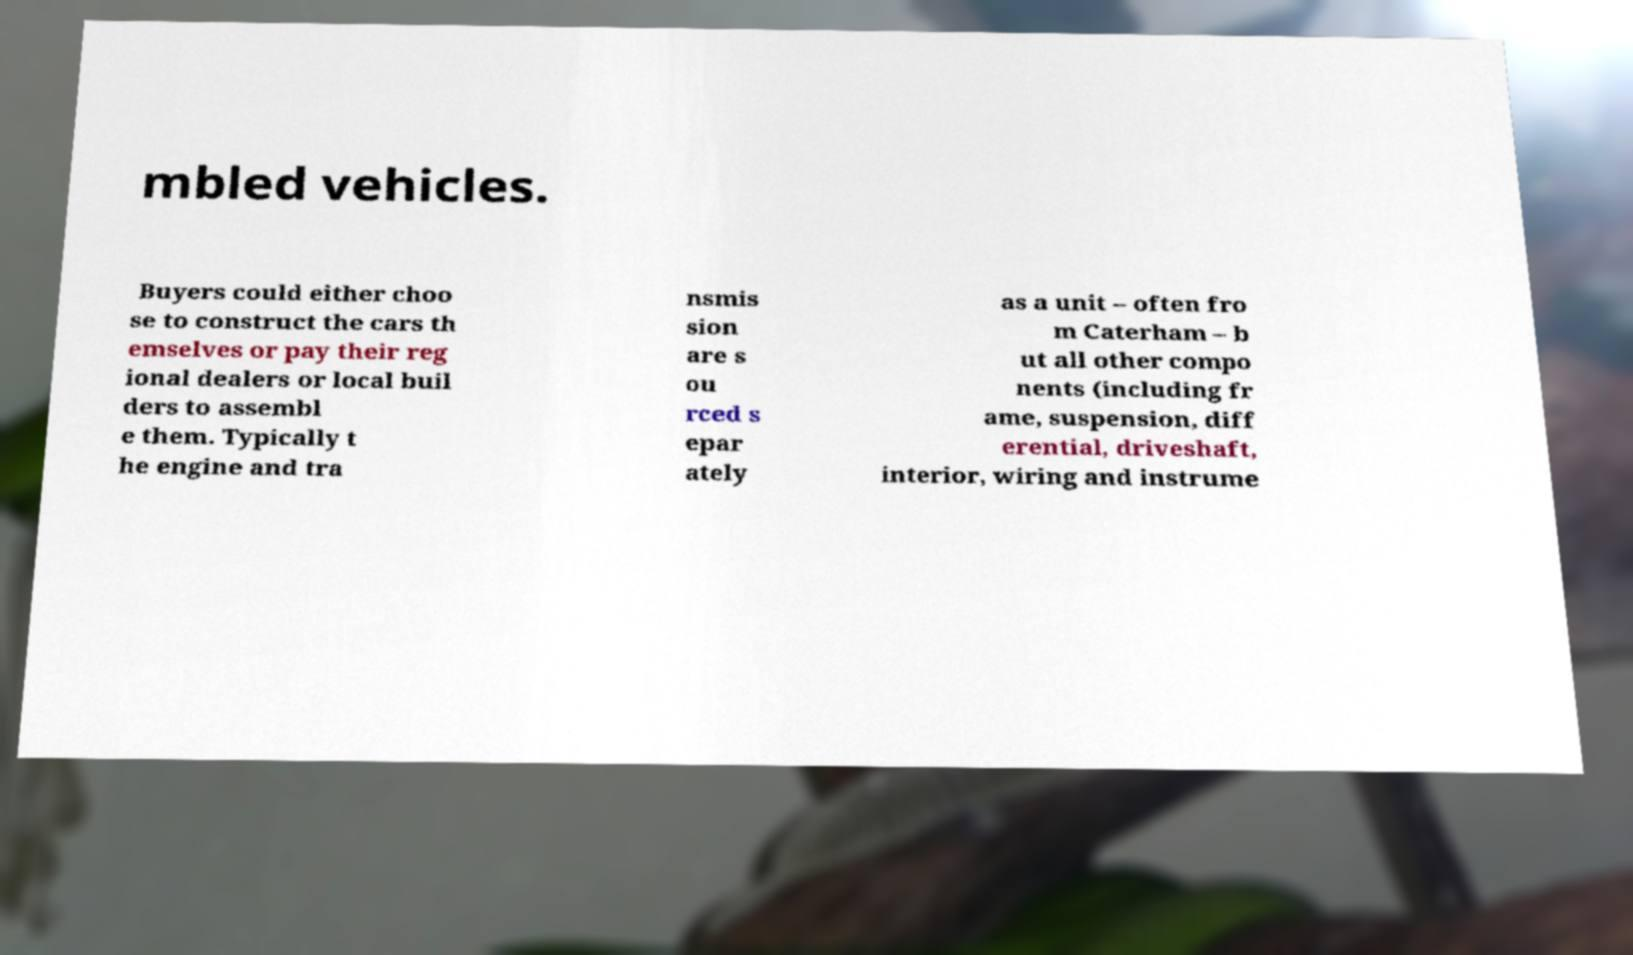There's text embedded in this image that I need extracted. Can you transcribe it verbatim? mbled vehicles. Buyers could either choo se to construct the cars th emselves or pay their reg ional dealers or local buil ders to assembl e them. Typically t he engine and tra nsmis sion are s ou rced s epar ately as a unit – often fro m Caterham – b ut all other compo nents (including fr ame, suspension, diff erential, driveshaft, interior, wiring and instrume 